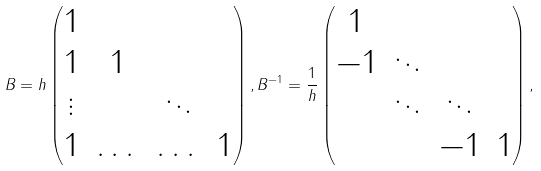<formula> <loc_0><loc_0><loc_500><loc_500>B = h \begin{pmatrix} 1 & & & \\ 1 & 1 & & \\ \vdots & & \ddots & \\ 1 & \dots & \dots & 1 \end{pmatrix} , B ^ { - 1 } = \frac { 1 } { h } \begin{pmatrix} 1 & & & \\ - 1 & \ddots & & \\ & \ddots & \ddots & \\ & & - 1 & 1 \end{pmatrix} ,</formula> 